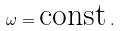<formula> <loc_0><loc_0><loc_500><loc_500>\omega = \text {const} \, .</formula> 